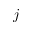Convert formula to latex. <formula><loc_0><loc_0><loc_500><loc_500>j</formula> 